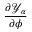<formula> <loc_0><loc_0><loc_500><loc_500>\frac { \partial { \ m a t h s c r Y } _ { \alpha } } { \partial \phi }</formula> 